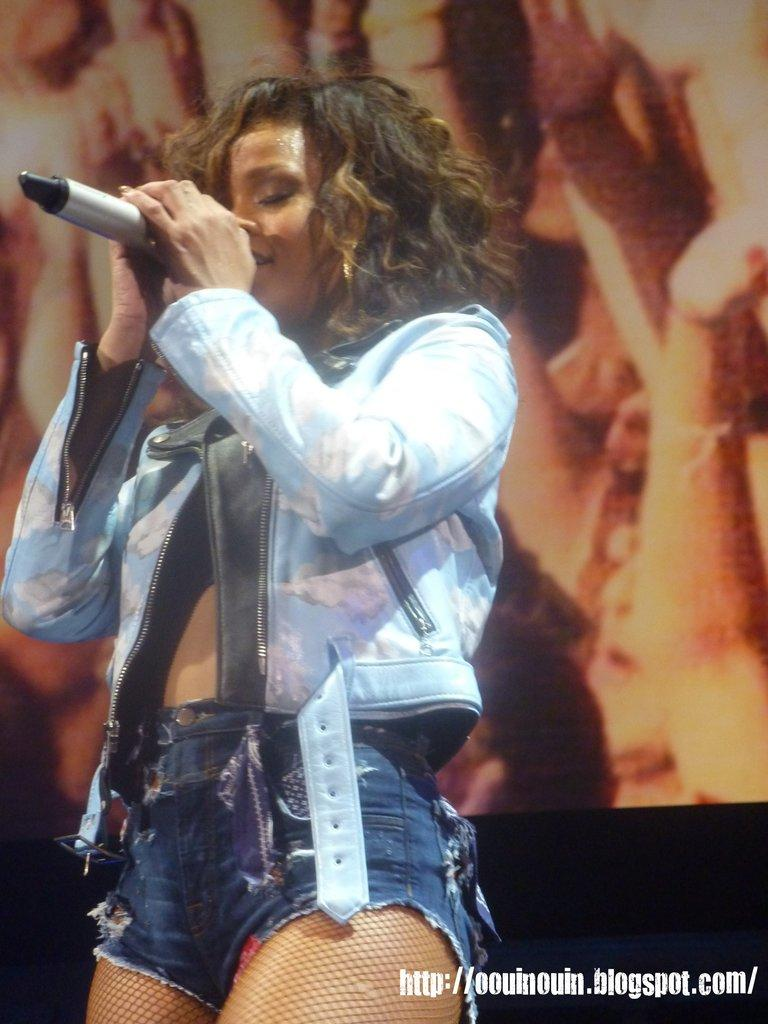What is the main subject of the image? The main subject of the image is a woman. What is the woman doing in the image? The woman is standing in the image. What object is the woman holding in her hand? The woman is holding a mic in her hand. What type of card is the woman holding in the image? The woman is not holding a card in the image; she is holding a mic. Can you tell me how many people are in jail in the image? There is no reference to a jail or any people being in jail in the image. 